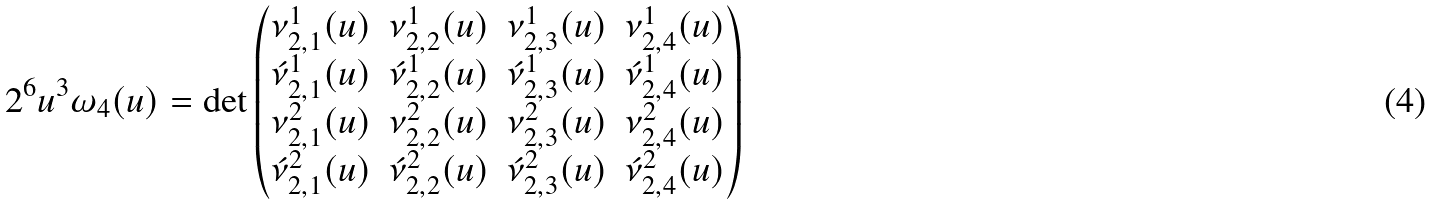Convert formula to latex. <formula><loc_0><loc_0><loc_500><loc_500>2 ^ { 6 } u ^ { 3 } \omega _ { 4 } ( u ) = \det \begin{pmatrix} \nu ^ { 1 } _ { 2 , 1 } ( u ) & \nu ^ { 1 } _ { 2 , 2 } ( u ) & \nu ^ { 1 } _ { 2 , 3 } ( u ) & \nu ^ { 1 } _ { 2 , 4 } ( u ) \\ \acute { \nu } ^ { 1 } _ { 2 , 1 } ( u ) & \acute { \nu } ^ { 1 } _ { 2 , 2 } ( u ) & \acute { \nu } ^ { 1 } _ { 2 , 3 } ( u ) & \acute { \nu } ^ { 1 } _ { 2 , 4 } ( u ) \\ \nu ^ { 2 } _ { 2 , 1 } ( u ) & \nu ^ { 2 } _ { 2 , 2 } ( u ) & \nu ^ { 2 } _ { 2 , 3 } ( u ) & \nu ^ { 2 } _ { 2 , 4 } ( u ) \\ \acute { \nu } ^ { 2 } _ { 2 , 1 } ( u ) & \acute { \nu } ^ { 2 } _ { 2 , 2 } ( u ) & \acute { \nu } ^ { 2 } _ { 2 , 3 } ( u ) & \acute { \nu } ^ { 2 } _ { 2 , 4 } ( u ) \\ \end{pmatrix}</formula> 